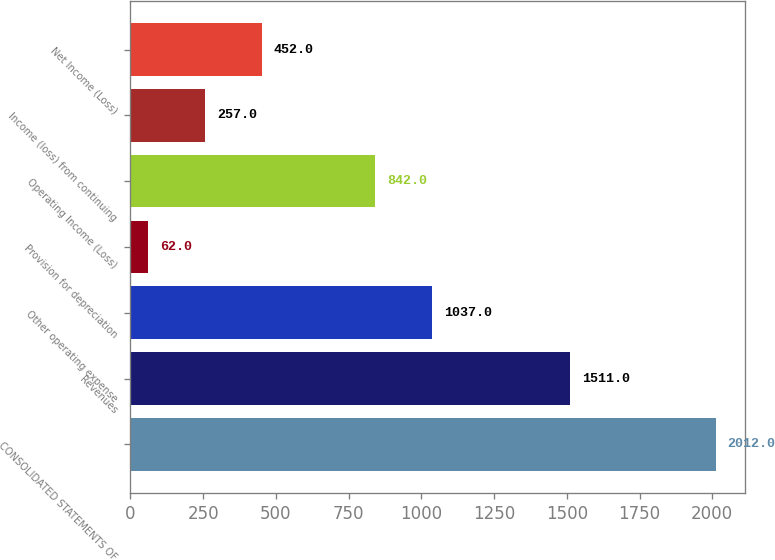Convert chart. <chart><loc_0><loc_0><loc_500><loc_500><bar_chart><fcel>CONSOLIDATED STATEMENTS OF<fcel>Revenues<fcel>Other operating expense<fcel>Provision for depreciation<fcel>Operating Income (Loss)<fcel>Income (loss) from continuing<fcel>Net Income (Loss)<nl><fcel>2012<fcel>1511<fcel>1037<fcel>62<fcel>842<fcel>257<fcel>452<nl></chart> 